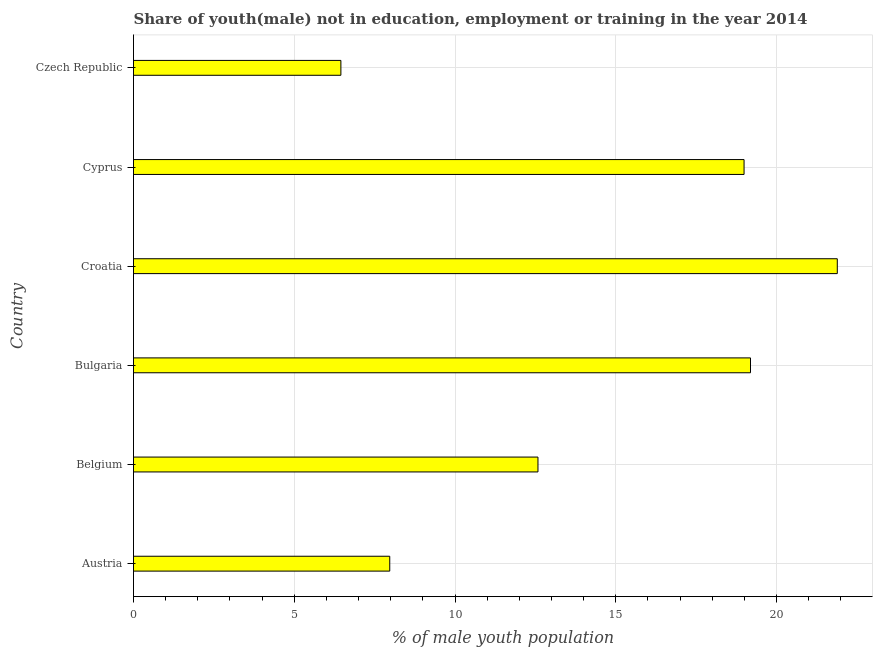What is the title of the graph?
Your answer should be very brief. Share of youth(male) not in education, employment or training in the year 2014. What is the label or title of the X-axis?
Your answer should be very brief. % of male youth population. What is the label or title of the Y-axis?
Your answer should be compact. Country. What is the unemployed male youth population in Czech Republic?
Provide a short and direct response. 6.45. Across all countries, what is the maximum unemployed male youth population?
Offer a terse response. 21.89. Across all countries, what is the minimum unemployed male youth population?
Provide a short and direct response. 6.45. In which country was the unemployed male youth population maximum?
Your answer should be very brief. Croatia. In which country was the unemployed male youth population minimum?
Offer a terse response. Czech Republic. What is the sum of the unemployed male youth population?
Offer a terse response. 87.07. What is the average unemployed male youth population per country?
Make the answer very short. 14.51. What is the median unemployed male youth population?
Offer a terse response. 15.78. In how many countries, is the unemployed male youth population greater than 19 %?
Your response must be concise. 2. What is the ratio of the unemployed male youth population in Croatia to that in Cyprus?
Your response must be concise. 1.15. Is the unemployed male youth population in Cyprus less than that in Czech Republic?
Provide a succinct answer. No. What is the difference between the highest and the second highest unemployed male youth population?
Provide a succinct answer. 2.7. Is the sum of the unemployed male youth population in Bulgaria and Croatia greater than the maximum unemployed male youth population across all countries?
Offer a terse response. Yes. What is the difference between the highest and the lowest unemployed male youth population?
Ensure brevity in your answer.  15.44. In how many countries, is the unemployed male youth population greater than the average unemployed male youth population taken over all countries?
Your answer should be compact. 3. How many bars are there?
Keep it short and to the point. 6. How many countries are there in the graph?
Give a very brief answer. 6. What is the difference between two consecutive major ticks on the X-axis?
Your answer should be compact. 5. What is the % of male youth population in Austria?
Provide a short and direct response. 7.97. What is the % of male youth population in Belgium?
Keep it short and to the point. 12.58. What is the % of male youth population of Bulgaria?
Give a very brief answer. 19.19. What is the % of male youth population of Croatia?
Offer a terse response. 21.89. What is the % of male youth population in Cyprus?
Make the answer very short. 18.99. What is the % of male youth population in Czech Republic?
Offer a terse response. 6.45. What is the difference between the % of male youth population in Austria and Belgium?
Ensure brevity in your answer.  -4.61. What is the difference between the % of male youth population in Austria and Bulgaria?
Keep it short and to the point. -11.22. What is the difference between the % of male youth population in Austria and Croatia?
Keep it short and to the point. -13.92. What is the difference between the % of male youth population in Austria and Cyprus?
Make the answer very short. -11.02. What is the difference between the % of male youth population in Austria and Czech Republic?
Offer a terse response. 1.52. What is the difference between the % of male youth population in Belgium and Bulgaria?
Offer a very short reply. -6.61. What is the difference between the % of male youth population in Belgium and Croatia?
Your response must be concise. -9.31. What is the difference between the % of male youth population in Belgium and Cyprus?
Provide a succinct answer. -6.41. What is the difference between the % of male youth population in Belgium and Czech Republic?
Provide a short and direct response. 6.13. What is the difference between the % of male youth population in Bulgaria and Croatia?
Ensure brevity in your answer.  -2.7. What is the difference between the % of male youth population in Bulgaria and Cyprus?
Your answer should be very brief. 0.2. What is the difference between the % of male youth population in Bulgaria and Czech Republic?
Your response must be concise. 12.74. What is the difference between the % of male youth population in Croatia and Cyprus?
Make the answer very short. 2.9. What is the difference between the % of male youth population in Croatia and Czech Republic?
Keep it short and to the point. 15.44. What is the difference between the % of male youth population in Cyprus and Czech Republic?
Your response must be concise. 12.54. What is the ratio of the % of male youth population in Austria to that in Belgium?
Offer a terse response. 0.63. What is the ratio of the % of male youth population in Austria to that in Bulgaria?
Give a very brief answer. 0.41. What is the ratio of the % of male youth population in Austria to that in Croatia?
Offer a terse response. 0.36. What is the ratio of the % of male youth population in Austria to that in Cyprus?
Offer a terse response. 0.42. What is the ratio of the % of male youth population in Austria to that in Czech Republic?
Ensure brevity in your answer.  1.24. What is the ratio of the % of male youth population in Belgium to that in Bulgaria?
Provide a succinct answer. 0.66. What is the ratio of the % of male youth population in Belgium to that in Croatia?
Your answer should be compact. 0.57. What is the ratio of the % of male youth population in Belgium to that in Cyprus?
Provide a short and direct response. 0.66. What is the ratio of the % of male youth population in Belgium to that in Czech Republic?
Your answer should be very brief. 1.95. What is the ratio of the % of male youth population in Bulgaria to that in Croatia?
Your answer should be compact. 0.88. What is the ratio of the % of male youth population in Bulgaria to that in Cyprus?
Provide a succinct answer. 1.01. What is the ratio of the % of male youth population in Bulgaria to that in Czech Republic?
Provide a succinct answer. 2.98. What is the ratio of the % of male youth population in Croatia to that in Cyprus?
Keep it short and to the point. 1.15. What is the ratio of the % of male youth population in Croatia to that in Czech Republic?
Your response must be concise. 3.39. What is the ratio of the % of male youth population in Cyprus to that in Czech Republic?
Your response must be concise. 2.94. 